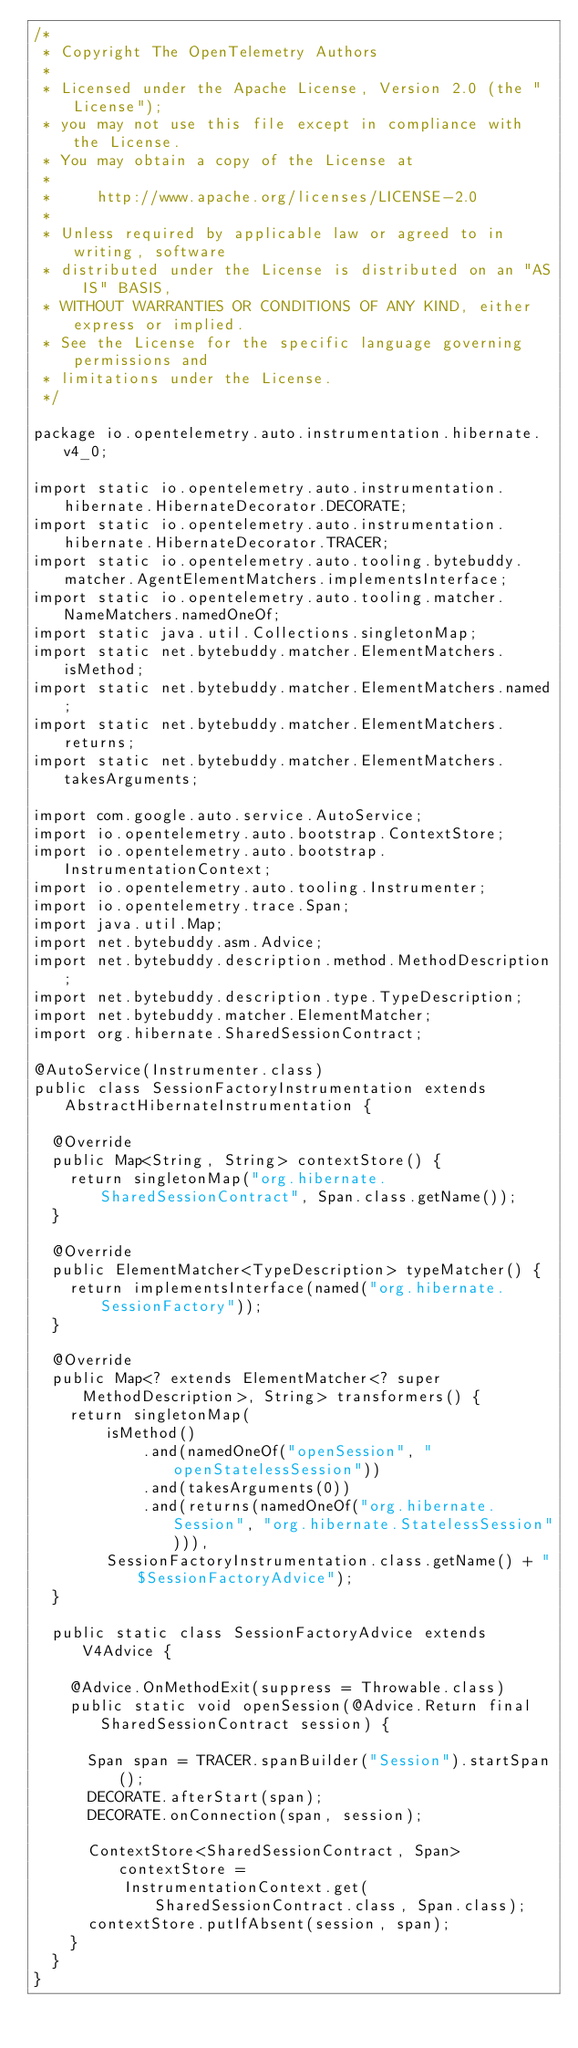<code> <loc_0><loc_0><loc_500><loc_500><_Java_>/*
 * Copyright The OpenTelemetry Authors
 *
 * Licensed under the Apache License, Version 2.0 (the "License");
 * you may not use this file except in compliance with the License.
 * You may obtain a copy of the License at
 *
 *     http://www.apache.org/licenses/LICENSE-2.0
 *
 * Unless required by applicable law or agreed to in writing, software
 * distributed under the License is distributed on an "AS IS" BASIS,
 * WITHOUT WARRANTIES OR CONDITIONS OF ANY KIND, either express or implied.
 * See the License for the specific language governing permissions and
 * limitations under the License.
 */

package io.opentelemetry.auto.instrumentation.hibernate.v4_0;

import static io.opentelemetry.auto.instrumentation.hibernate.HibernateDecorator.DECORATE;
import static io.opentelemetry.auto.instrumentation.hibernate.HibernateDecorator.TRACER;
import static io.opentelemetry.auto.tooling.bytebuddy.matcher.AgentElementMatchers.implementsInterface;
import static io.opentelemetry.auto.tooling.matcher.NameMatchers.namedOneOf;
import static java.util.Collections.singletonMap;
import static net.bytebuddy.matcher.ElementMatchers.isMethod;
import static net.bytebuddy.matcher.ElementMatchers.named;
import static net.bytebuddy.matcher.ElementMatchers.returns;
import static net.bytebuddy.matcher.ElementMatchers.takesArguments;

import com.google.auto.service.AutoService;
import io.opentelemetry.auto.bootstrap.ContextStore;
import io.opentelemetry.auto.bootstrap.InstrumentationContext;
import io.opentelemetry.auto.tooling.Instrumenter;
import io.opentelemetry.trace.Span;
import java.util.Map;
import net.bytebuddy.asm.Advice;
import net.bytebuddy.description.method.MethodDescription;
import net.bytebuddy.description.type.TypeDescription;
import net.bytebuddy.matcher.ElementMatcher;
import org.hibernate.SharedSessionContract;

@AutoService(Instrumenter.class)
public class SessionFactoryInstrumentation extends AbstractHibernateInstrumentation {

  @Override
  public Map<String, String> contextStore() {
    return singletonMap("org.hibernate.SharedSessionContract", Span.class.getName());
  }

  @Override
  public ElementMatcher<TypeDescription> typeMatcher() {
    return implementsInterface(named("org.hibernate.SessionFactory"));
  }

  @Override
  public Map<? extends ElementMatcher<? super MethodDescription>, String> transformers() {
    return singletonMap(
        isMethod()
            .and(namedOneOf("openSession", "openStatelessSession"))
            .and(takesArguments(0))
            .and(returns(namedOneOf("org.hibernate.Session", "org.hibernate.StatelessSession"))),
        SessionFactoryInstrumentation.class.getName() + "$SessionFactoryAdvice");
  }

  public static class SessionFactoryAdvice extends V4Advice {

    @Advice.OnMethodExit(suppress = Throwable.class)
    public static void openSession(@Advice.Return final SharedSessionContract session) {

      Span span = TRACER.spanBuilder("Session").startSpan();
      DECORATE.afterStart(span);
      DECORATE.onConnection(span, session);

      ContextStore<SharedSessionContract, Span> contextStore =
          InstrumentationContext.get(SharedSessionContract.class, Span.class);
      contextStore.putIfAbsent(session, span);
    }
  }
}
</code> 